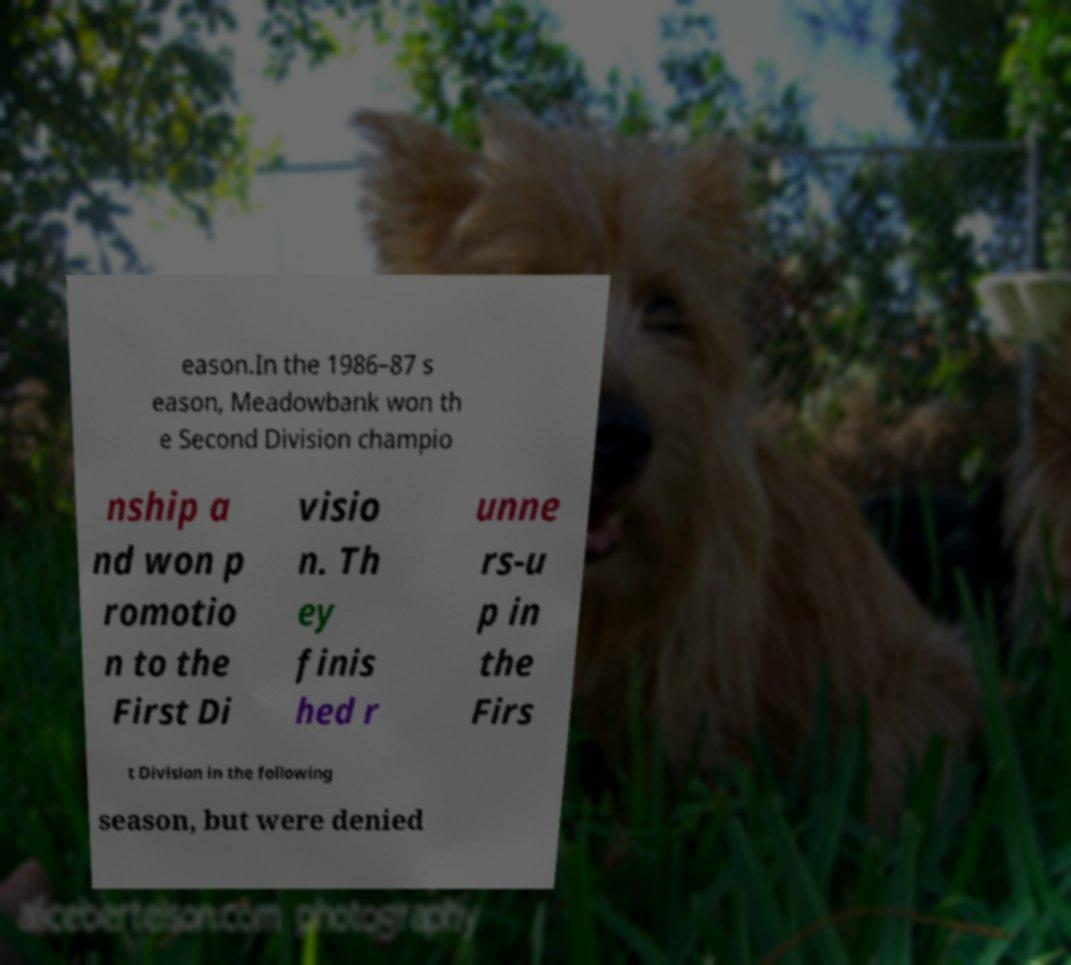Could you assist in decoding the text presented in this image and type it out clearly? eason.In the 1986–87 s eason, Meadowbank won th e Second Division champio nship a nd won p romotio n to the First Di visio n. Th ey finis hed r unne rs-u p in the Firs t Division in the following season, but were denied 